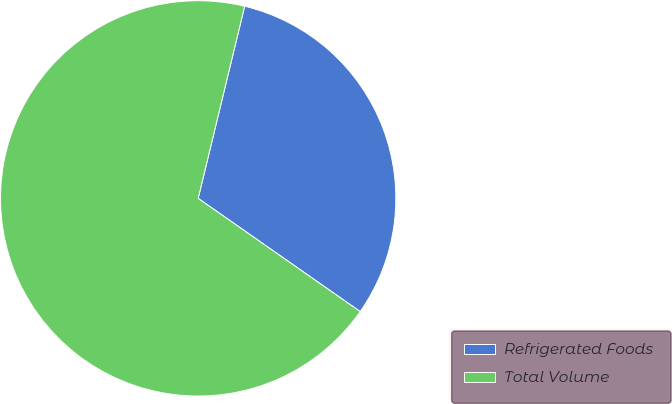Convert chart to OTSL. <chart><loc_0><loc_0><loc_500><loc_500><pie_chart><fcel>Refrigerated Foods<fcel>Total Volume<nl><fcel>30.93%<fcel>69.07%<nl></chart> 